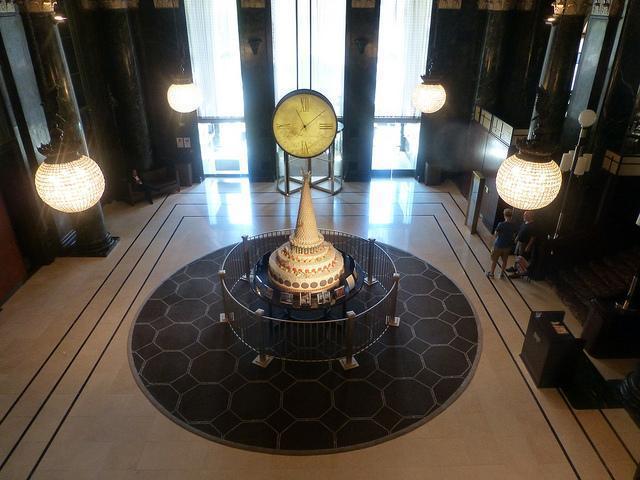How many clocks are visible?
Give a very brief answer. 1. How many white lines are on the road between the gray car and the white car in the foreground?
Give a very brief answer. 0. 